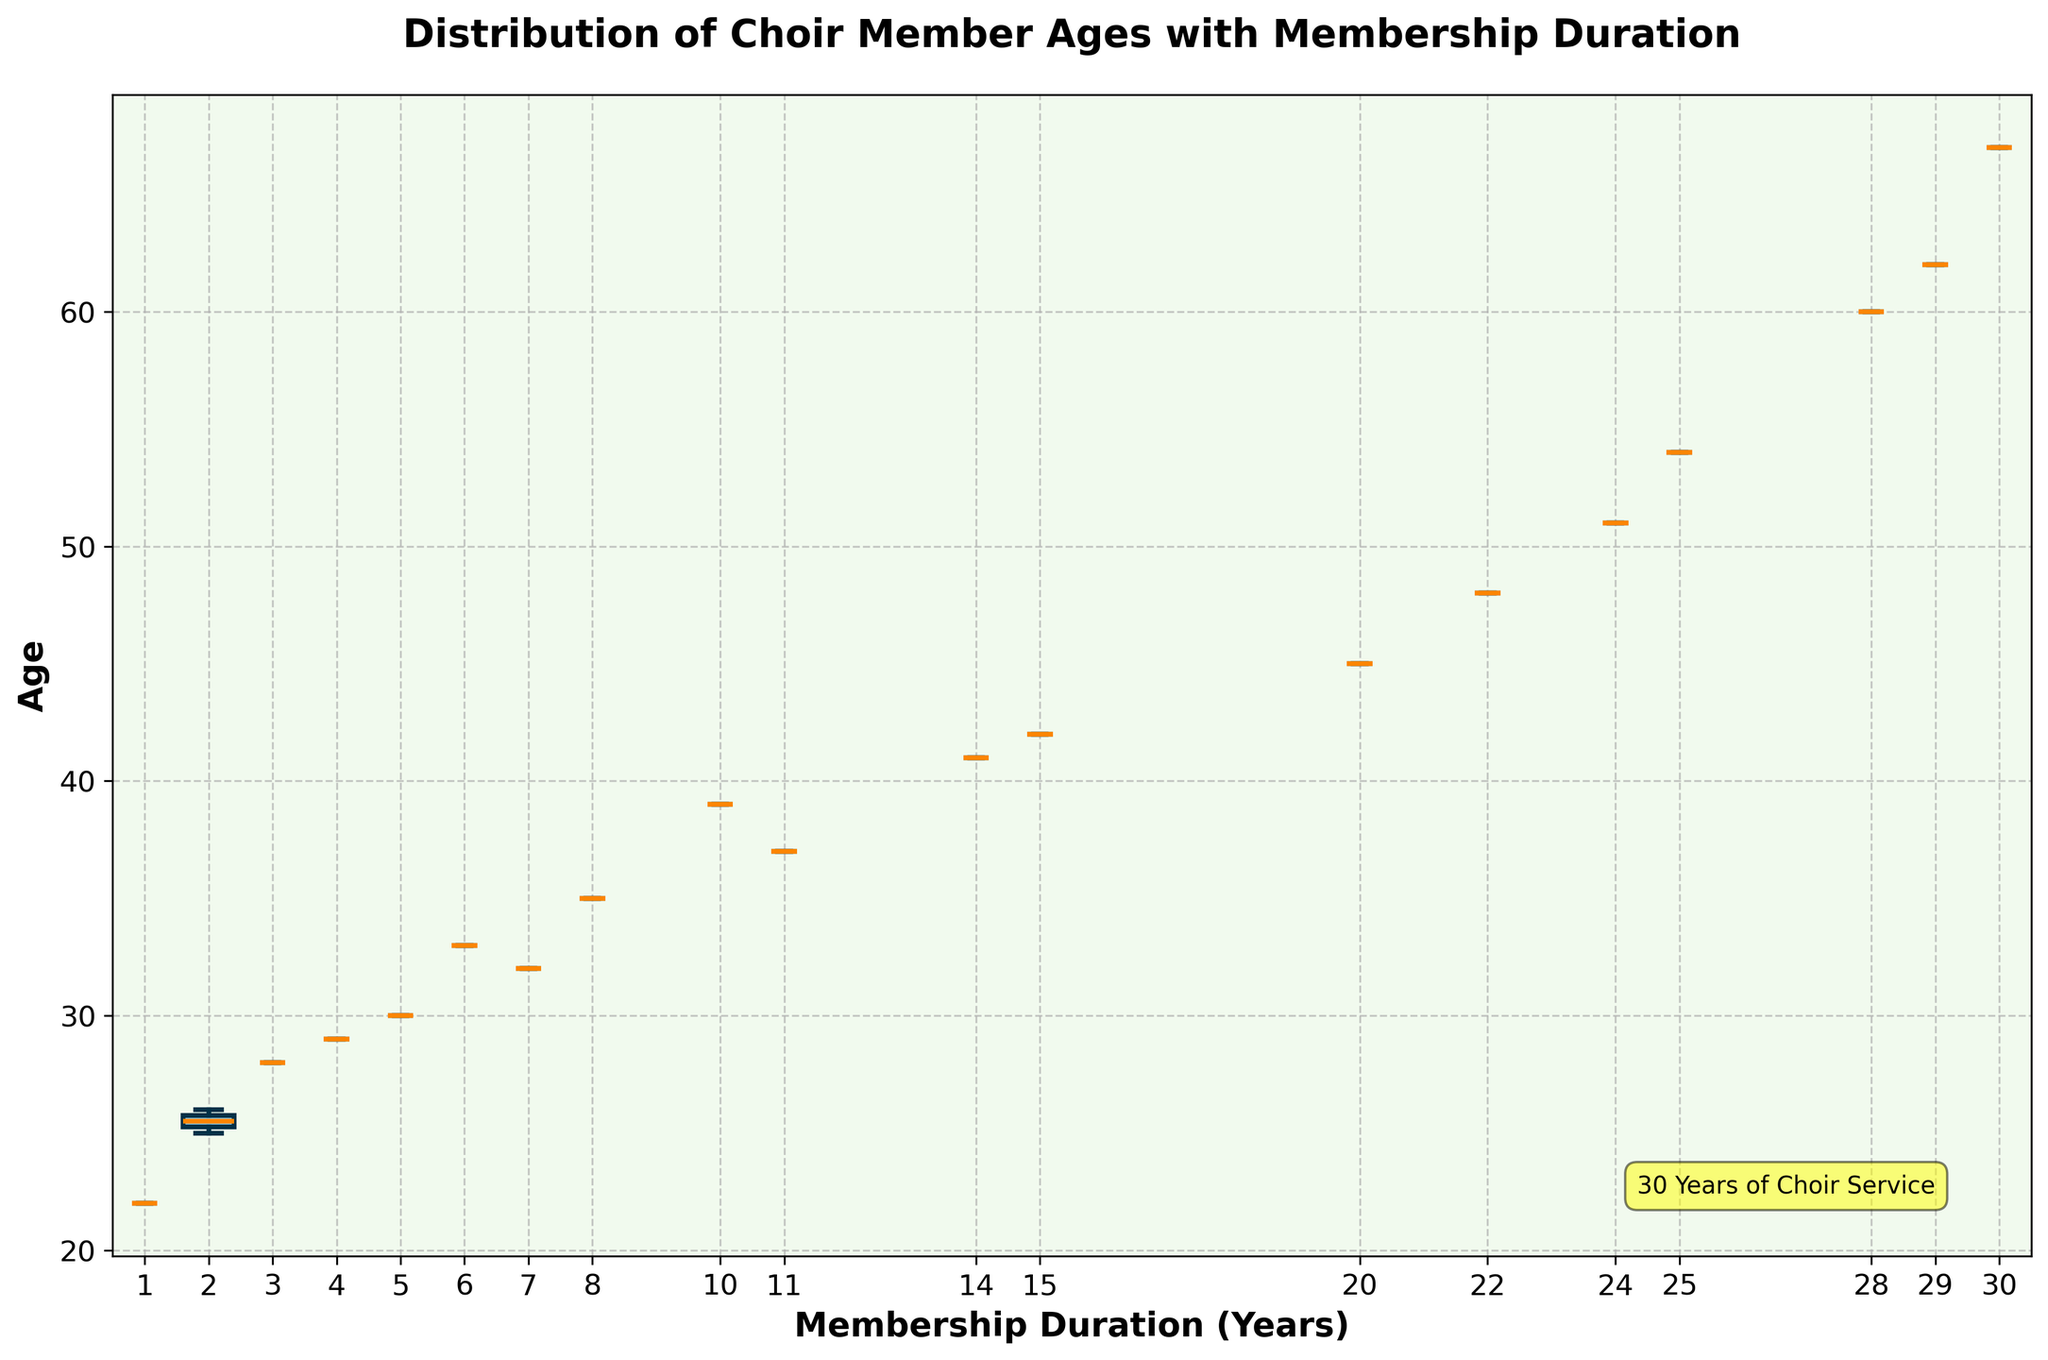What is the title of the figure? The title is given at the top of the figure as a descriptive label.
Answer: Distribution of Choir Member Ages with Membership Duration What color is used for the boxes in the box plot? The color is visually apparent from the figure.
Answer: Light Blue How many membership duration categories are there in the plot? By counting the unique positions on the x-axis, we can determine the number of categories.
Answer: 12 What is the median age for the group with a membership duration of 10 years? Find the line inside the box corresponding to the 10-year membership duration on the x-axis.
Answer: 39 Which group has the widest boxplot? The width of a boxplot is proportional to the number of members in that category. Visually compare the widths of all boxplots.
Answer: 2 years What can you infer about the age distribution for choir members with long membership durations? Analyze the spread, median, and range of ages for groups with longer membership durations (20+ years). Typically, the boxes will give a clue to the spread and medians indicate central tendencies.
Answer: Older age bias Which membership duration category has the smallest interquartile range (IQR)? Identify the category with the smallest spread between the first quartile (25th percentile) and the third quartile (75th percentile) within the box.
Answer: 5 years Are there any outliers in the data for membership duration of 28 years? Check if there are any points outside the whiskers of the box plot for the 28-year category.
Answer: No Which membership duration category has the oldest median age? Locate the highest median line among all categories.
Answer: 30 years How does the median age for the 4-year membership duration compare to the median age for the 20-year membership duration? Compare the median lines of the 4-year and 20-year categories.
Answer: The 20-year category has a higher median age than the 4-year category 